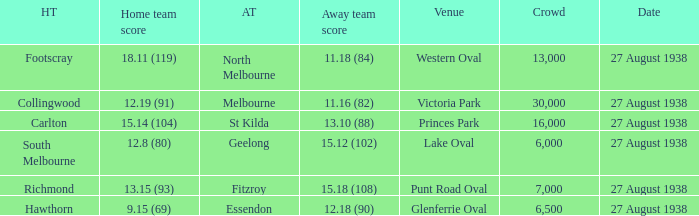What is the average crowd attendance for Collingwood? 30000.0. 